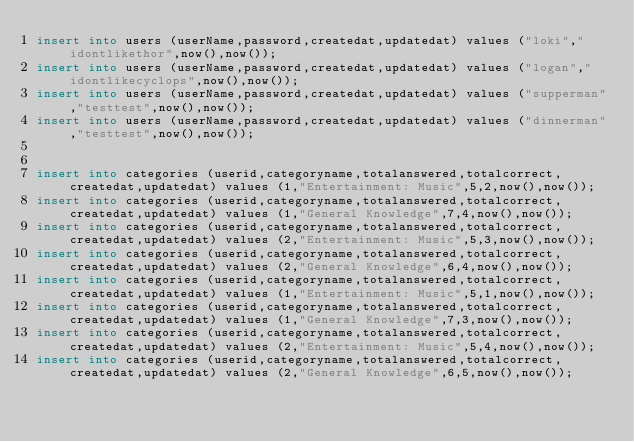<code> <loc_0><loc_0><loc_500><loc_500><_SQL_>insert into users (userName,password,createdat,updatedat) values ("loki","idontlikethor",now(),now());
insert into users (userName,password,createdat,updatedat) values ("logan","idontlikecyclops",now(),now());
insert into users (userName,password,createdat,updatedat) values ("supperman","testtest",now(),now());
insert into users (userName,password,createdat,updatedat) values ("dinnerman","testtest",now(),now());


insert into categories (userid,categoryname,totalanswered,totalcorrect,createdat,updatedat) values (1,"Entertainment: Music",5,2,now(),now());
insert into categories (userid,categoryname,totalanswered,totalcorrect,createdat,updatedat) values (1,"General Knowledge",7,4,now(),now());
insert into categories (userid,categoryname,totalanswered,totalcorrect,createdat,updatedat) values (2,"Entertainment: Music",5,3,now(),now());
insert into categories (userid,categoryname,totalanswered,totalcorrect,createdat,updatedat) values (2,"General Knowledge",6,4,now(),now());
insert into categories (userid,categoryname,totalanswered,totalcorrect,createdat,updatedat) values (1,"Entertainment: Music",5,1,now(),now());
insert into categories (userid,categoryname,totalanswered,totalcorrect,createdat,updatedat) values (1,"General Knowledge",7,3,now(),now());
insert into categories (userid,categoryname,totalanswered,totalcorrect,createdat,updatedat) values (2,"Entertainment: Music",5,4,now(),now());
insert into categories (userid,categoryname,totalanswered,totalcorrect,createdat,updatedat) values (2,"General Knowledge",6,5,now(),now());
</code> 